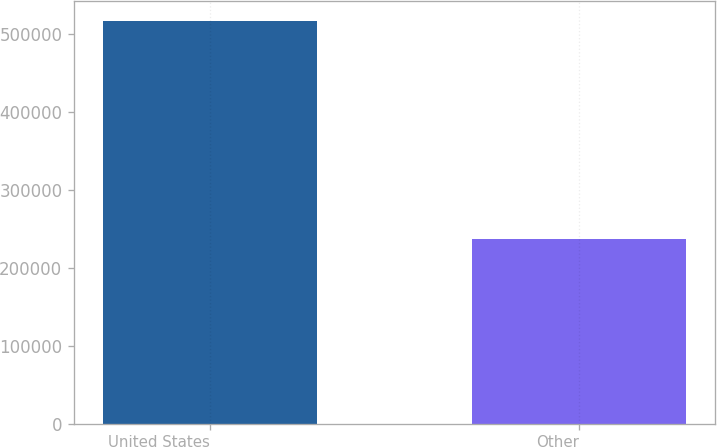Convert chart to OTSL. <chart><loc_0><loc_0><loc_500><loc_500><bar_chart><fcel>United States<fcel>Other<nl><fcel>517432<fcel>236698<nl></chart> 